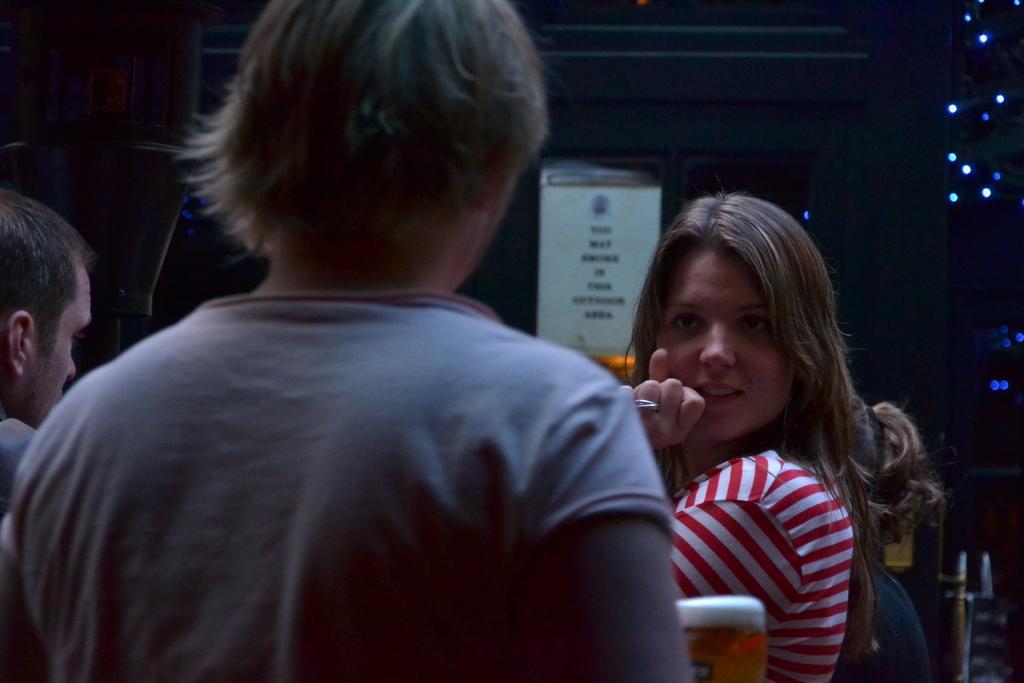Please provide a concise description of this image. In this picture we can see the women wearing a red and white striped t-shirt, standing and looking straight In the front we can see the boy. Behind there is a dark background. 